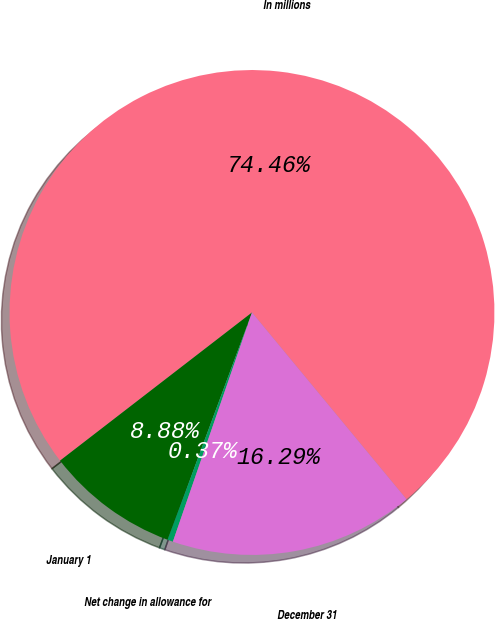Convert chart to OTSL. <chart><loc_0><loc_0><loc_500><loc_500><pie_chart><fcel>In millions<fcel>January 1<fcel>Net change in allowance for<fcel>December 31<nl><fcel>74.46%<fcel>8.88%<fcel>0.37%<fcel>16.29%<nl></chart> 